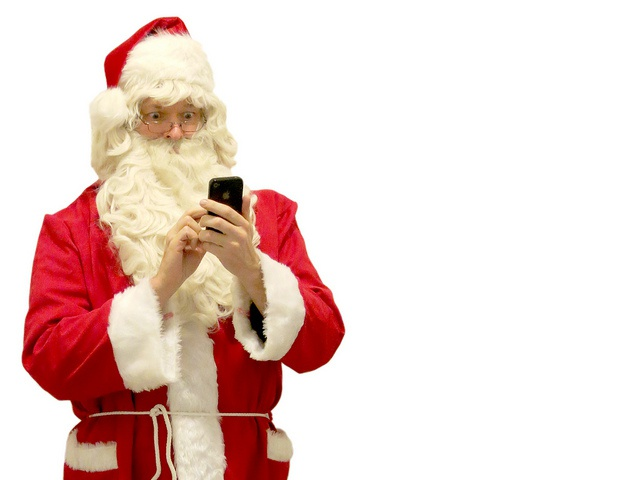Describe the objects in this image and their specific colors. I can see people in white, beige, maroon, tan, and brown tones and cell phone in white, black, darkgreen, maroon, and gray tones in this image. 